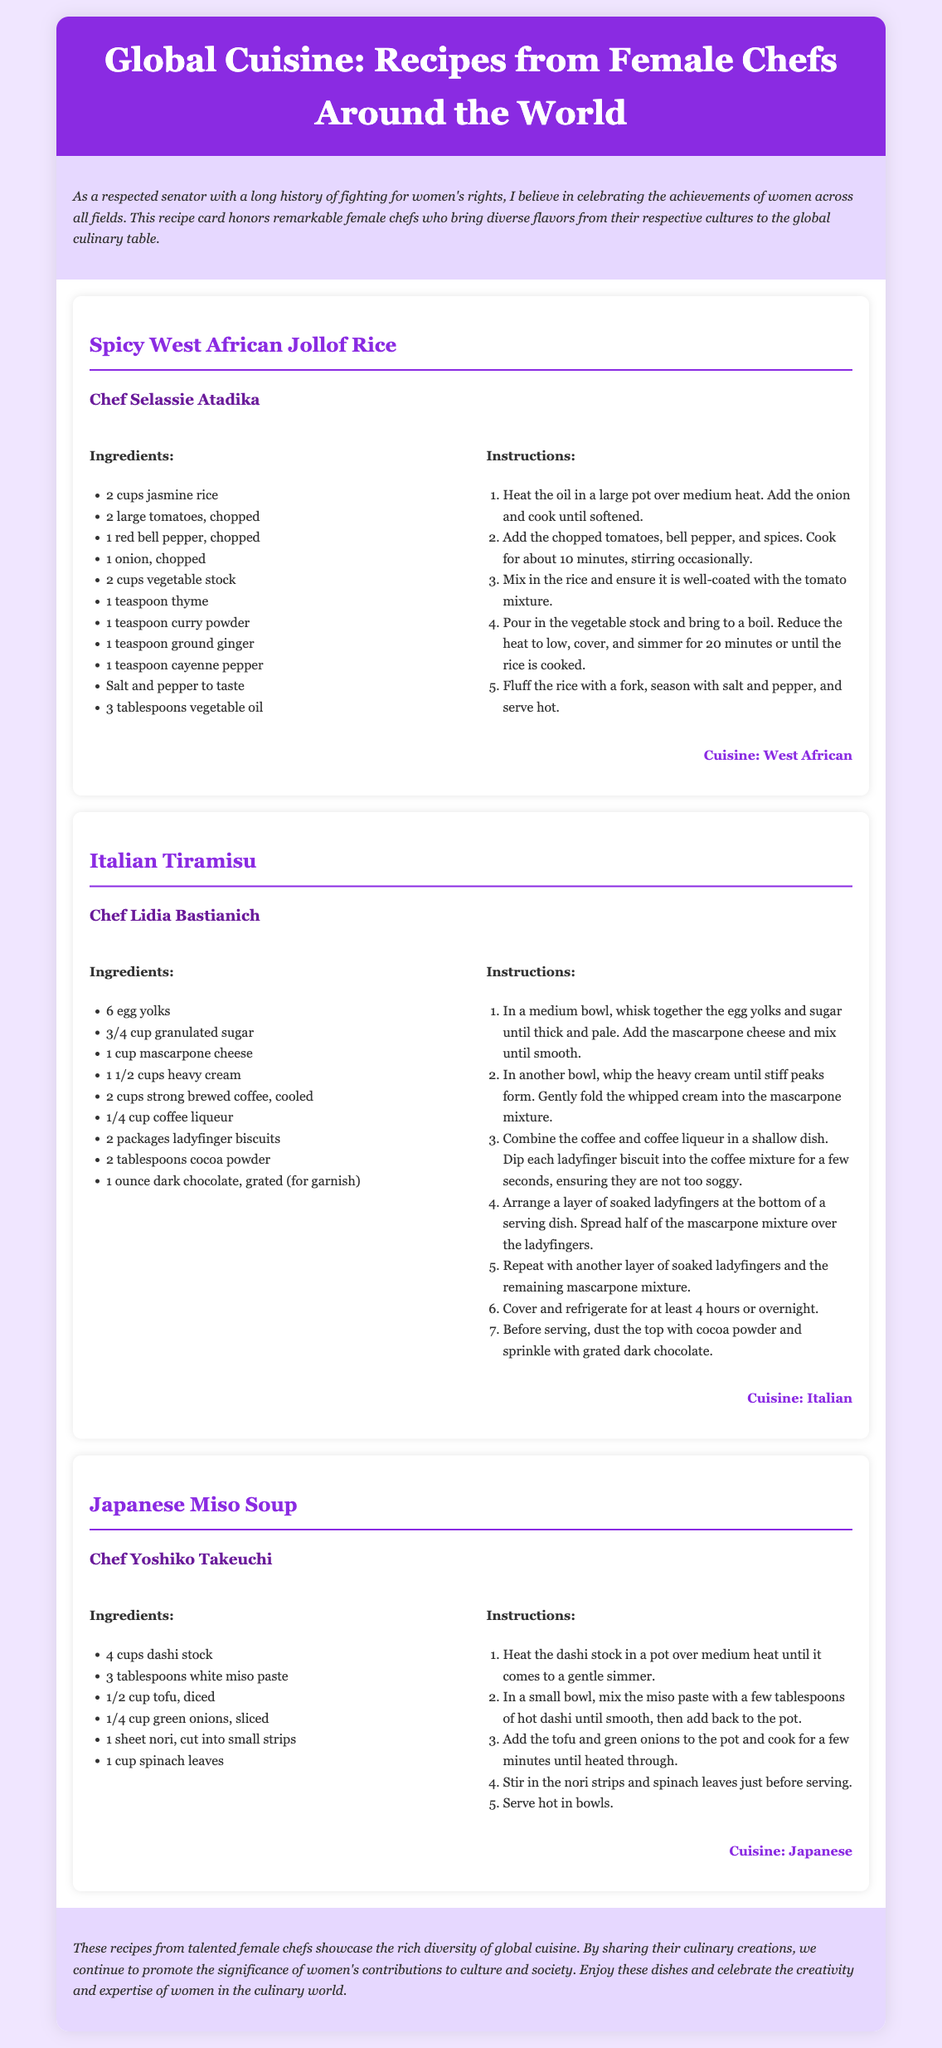What is the first recipe listed? The first recipe in the document is titled "Spicy West African Jollof Rice."
Answer: Spicy West African Jollof Rice Who is the chef for the Italian Tiramisu? The chef for the Italian Tiramisu is Lidia Bastianich.
Answer: Lidia Bastianich How many cups of jasmine rice are required for the Jollof Rice? The Jollof Rice recipe requires 2 cups of jasmine rice.
Answer: 2 cups What cuisine is the Japanese Miso Soup classified under? The Japanese Miso Soup is classified under Japanese cuisine.
Answer: Japanese What is a key ingredient in the Italian Tiramisu? A key ingredient in the Italian Tiramisu is mascarpone cheese.
Answer: mascarpone cheese Which recipe includes cayenne pepper? The recipe that includes cayenne pepper is the Spicy West African Jollof Rice.
Answer: Spicy West African Jollof Rice How many ingredients are listed for the Japanese Miso Soup? There are 6 ingredients listed for the Japanese Miso Soup.
Answer: 6 Which chef contributed a recipe for the West African cuisine? The chef who contributed a recipe for the West African cuisine is Selassie Atadika.
Answer: Selassie Atadika What is the final step before serving the Tiramisu? The final step before serving the Tiramisu is to dust the top with cocoa powder and sprinkle with grated dark chocolate.
Answer: Dust with cocoa powder and sprinkle with grated dark chocolate 